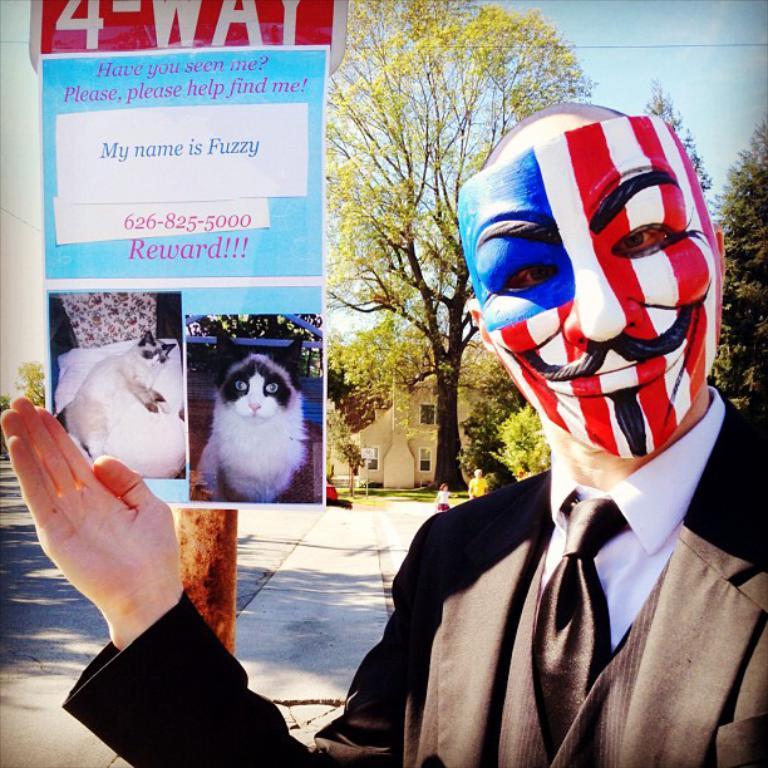Please provide a concise description of this image. In the foreground of the image there is a person wearing suit and a mask. In the background of the image there are trees, house. There is a pole with a board on it with some text and images of a cat. At the bottom of the image there is road. At the top of the image there is sky. 